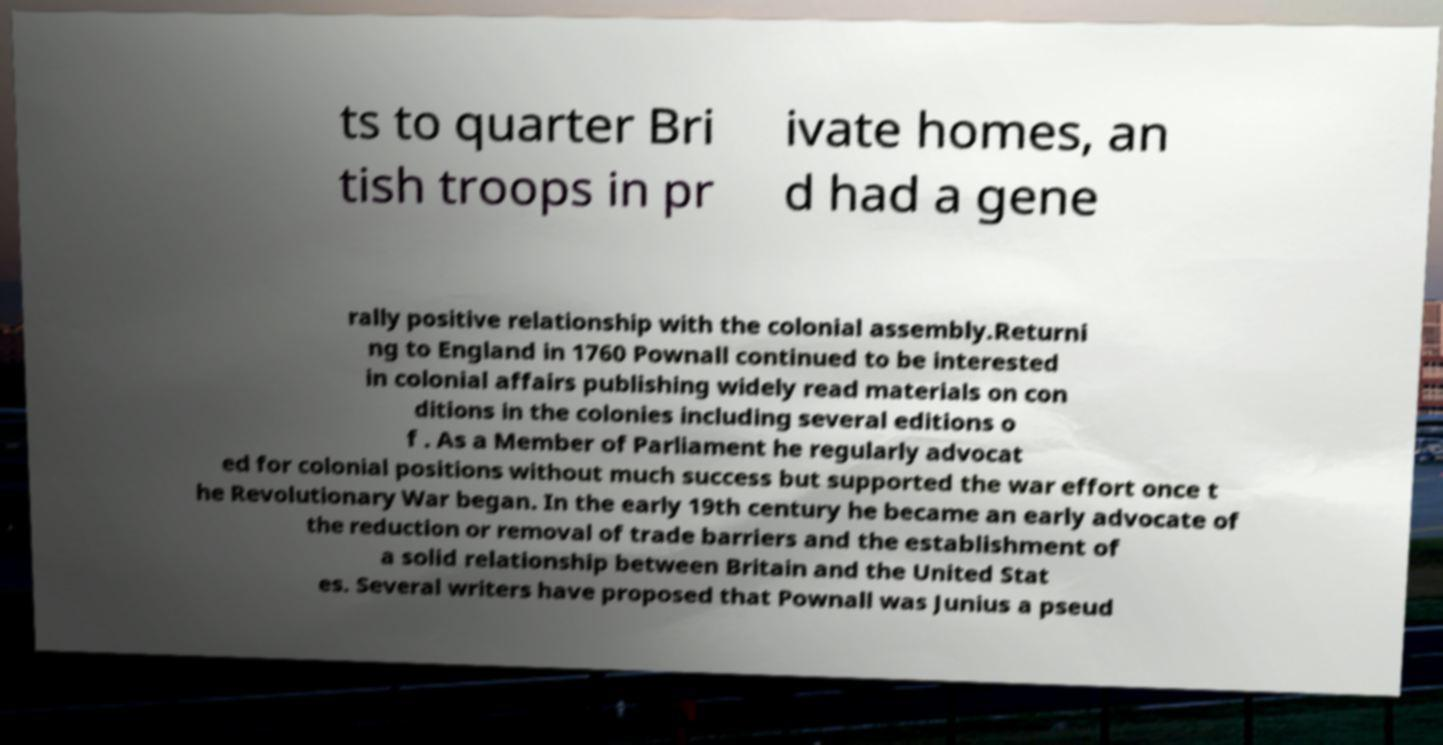Could you assist in decoding the text presented in this image and type it out clearly? ts to quarter Bri tish troops in pr ivate homes, an d had a gene rally positive relationship with the colonial assembly.Returni ng to England in 1760 Pownall continued to be interested in colonial affairs publishing widely read materials on con ditions in the colonies including several editions o f . As a Member of Parliament he regularly advocat ed for colonial positions without much success but supported the war effort once t he Revolutionary War began. In the early 19th century he became an early advocate of the reduction or removal of trade barriers and the establishment of a solid relationship between Britain and the United Stat es. Several writers have proposed that Pownall was Junius a pseud 